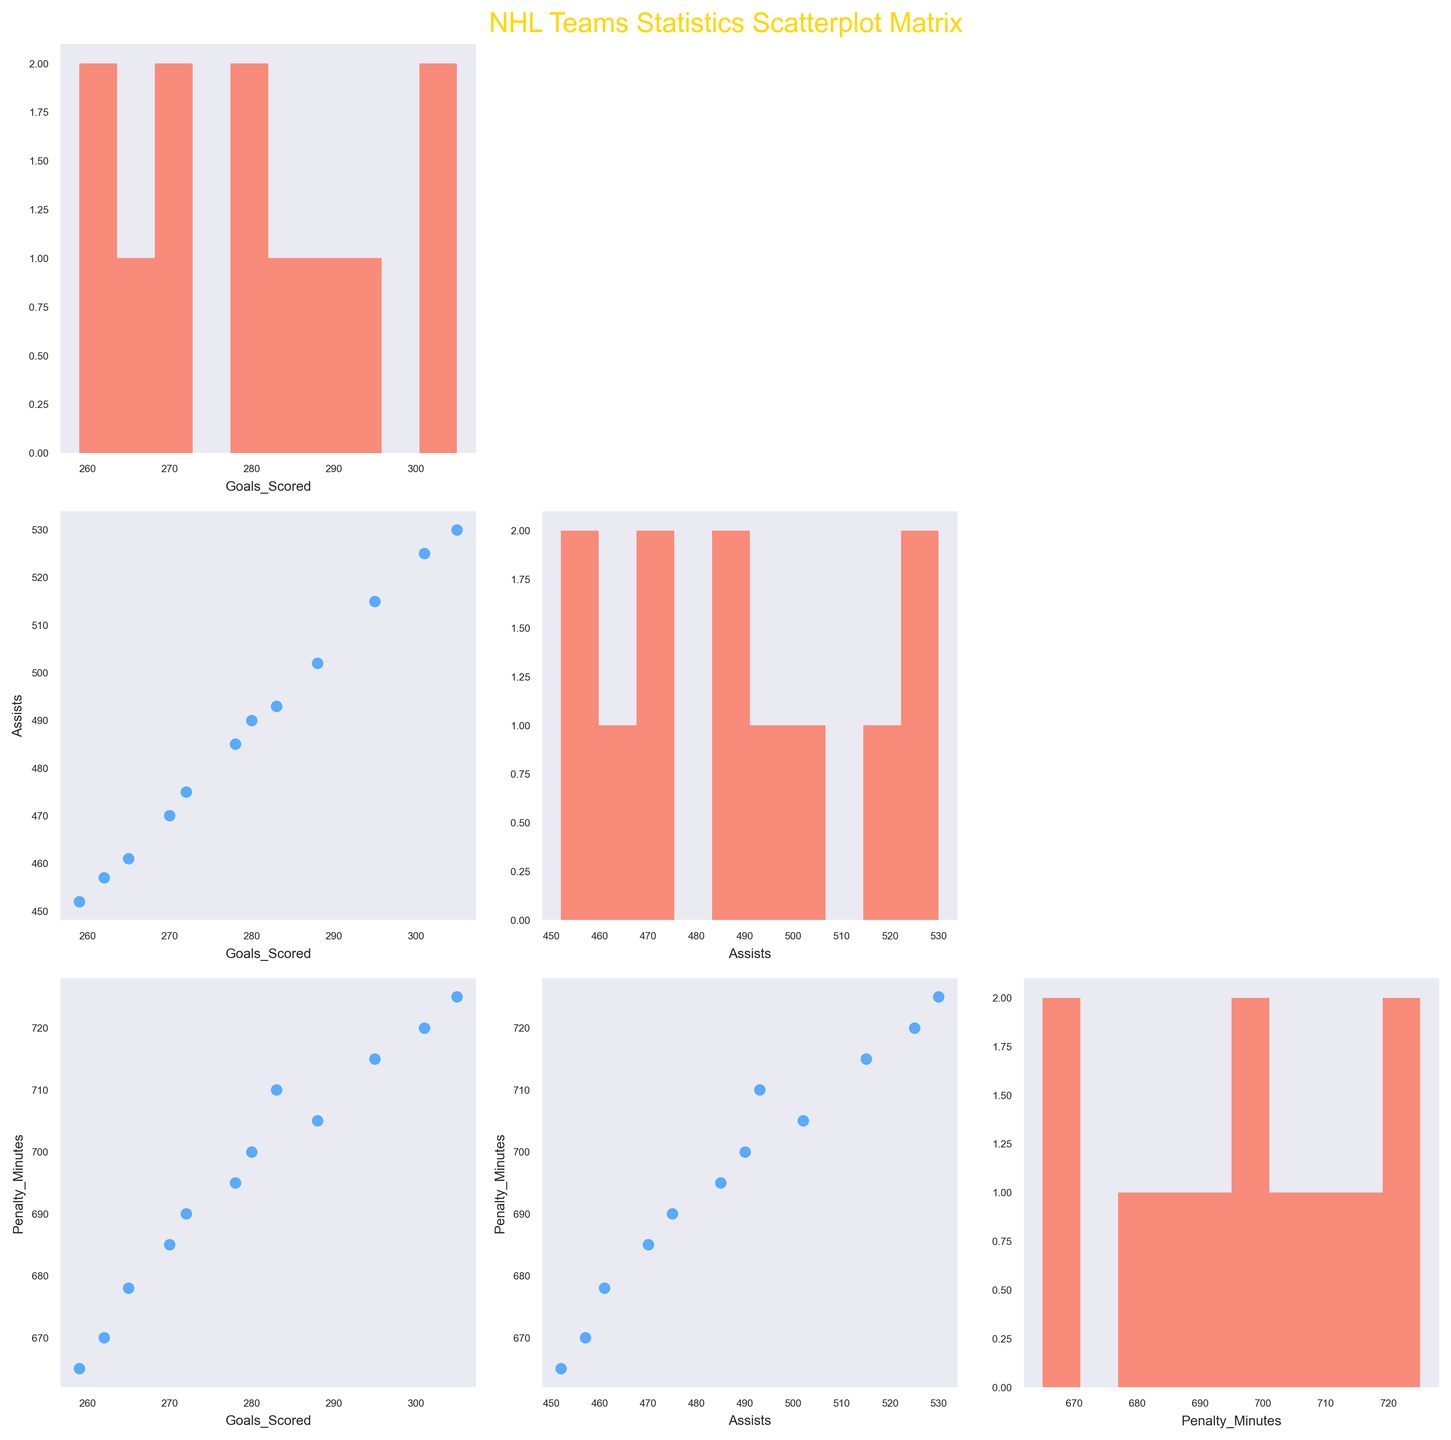What is the title of the figure? The title is usually displayed at the top of the plot. In this figure, it reads "NHL Teams Statistics Scatterplot Matrix".
Answer: NHL Teams Statistics Scatterplot Matrix Which color is used for the histogram bars representing the distribution of Goals Scored? In this scatterplot matrix, the histograms for individual variables use a distinctive color. The color used for the histogram bars of Goals Scored is a shade of red.
Answer: Red How many variables are compared in the scatterplot matrix? The scatterplot matrix compares a certain number of variables, each corresponding to a hockey statistic. By looking at the axes and the grid structure, we can count the number of distinct variables being compared.
Answer: Three Which data point has the highest number of assists, and what is that value? By examining the scatterplots that involve "Assists" on either axis, we can find the data point with the highest value. In the histogram for Assists, the peak value indicates the highest number. By cross-referencing the team names or data, we identify the team.
Answer: Colorado Avalanche with 530 Between Toronto Maple Leafs and Ottawa Senators, which team has fewer penalty minutes? To find this, we look at the scatterplots or histograms involving "Penalty_Minutes". Identifying the respective data points of the two teams and comparing their vertical positions or histogram bars will reveal this information.
Answer: Ottawa Senators Calculate the average number of goals scored across all teams. Sum up the Goals Scored values for all teams from the data and divide by the number of teams (12). (288 + 265 + 272 + 301 + 278 + 283 + 259 + 295 + 270 + 262 + 280 + 305)/12 = 3358/12
Answer: 279.83 Do teams with more assists tend to have more goals scored? Analyzing the scatterplot where Goals Scored is plotted against Assists shows trends and correlations. A rising trend in this plot suggests that teams with more assists also score more goals.
Answer: Yes What is the range of penalty minutes observed in the teams? The range is calculated by subtracting the minimum value of Penalty_Minutes from the maximum value. From the histograms or scatterplots, observe the extreme values for Penalty_Minutes. Range = 725 - 665
Answer: 60 Which team has the highest penalty minutes and is it more than 700? To identify the team, look at the scatterplot or histogram indicating Penalty_Minutes. The highest value on the corresponding axis or peak in the histogram bar will help identify the team and verify the value.
Answer: Colorado Avalanche with 725 In the scatterplot comparing Goals Scored and Assists, which team stands out as an outlier and why? An outlier is a data point that is significantly different from others. In the Goals Scored vs. Assists scatterplot, look for a team significantly distant from the cluster of points. Determine which team this is by checking their values.
Answer: Colorado Avalanche, it has the highest goals and assists with 305 goals and 530 assists 